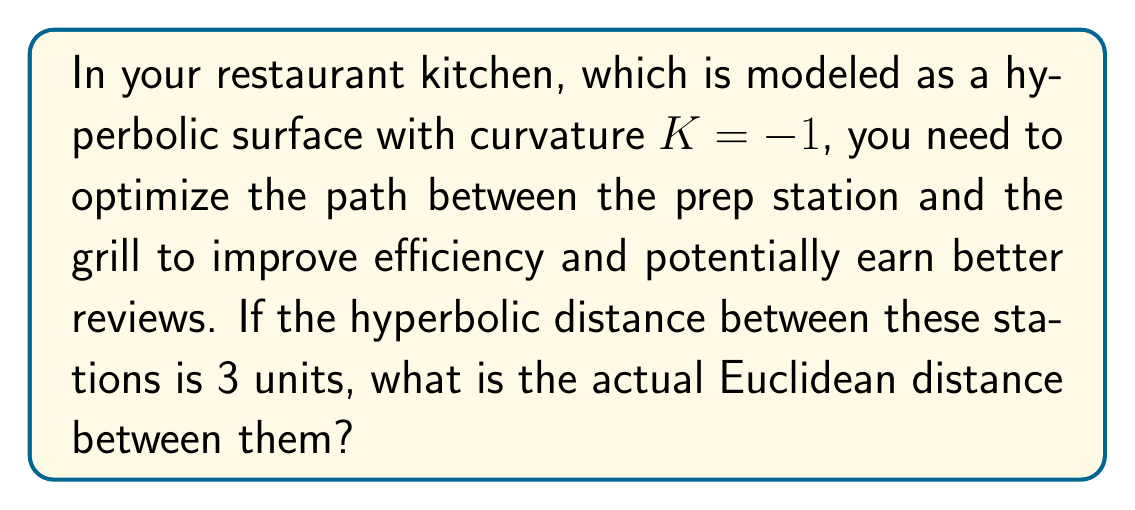Can you answer this question? Let's approach this step-by-step:

1) In hyperbolic geometry with curvature $K = -1$, the relationship between hyperbolic distance $d$ and Euclidean distance $r$ is given by:

   $$\cosh d = \cosh(\sqrt{-K}r)$$

2) Since $K = -1$, this simplifies to:

   $$\cosh d = \cosh r$$

3) We're given that the hyperbolic distance $d = 3$, so we can substitute this:

   $$\cosh 3 = \cosh r$$

4) To solve for $r$, we need to apply the inverse hyperbolic cosine (arccosh) to both sides:

   $$r = \text{arccosh}(\cosh 3)$$

5) The value of $\cosh 3$ can be calculated:

   $$\cosh 3 \approx 10.0676$$

6) Therefore:

   $$r = \text{arccosh}(10.0676)$$

7) Calculating this gives us:

   $$r \approx 2.9933$$

This means that while the hyperbolic distance is 3 units, the Euclidean distance is slightly less, approximately 2.9933 units.
Answer: $2.9933$ units 